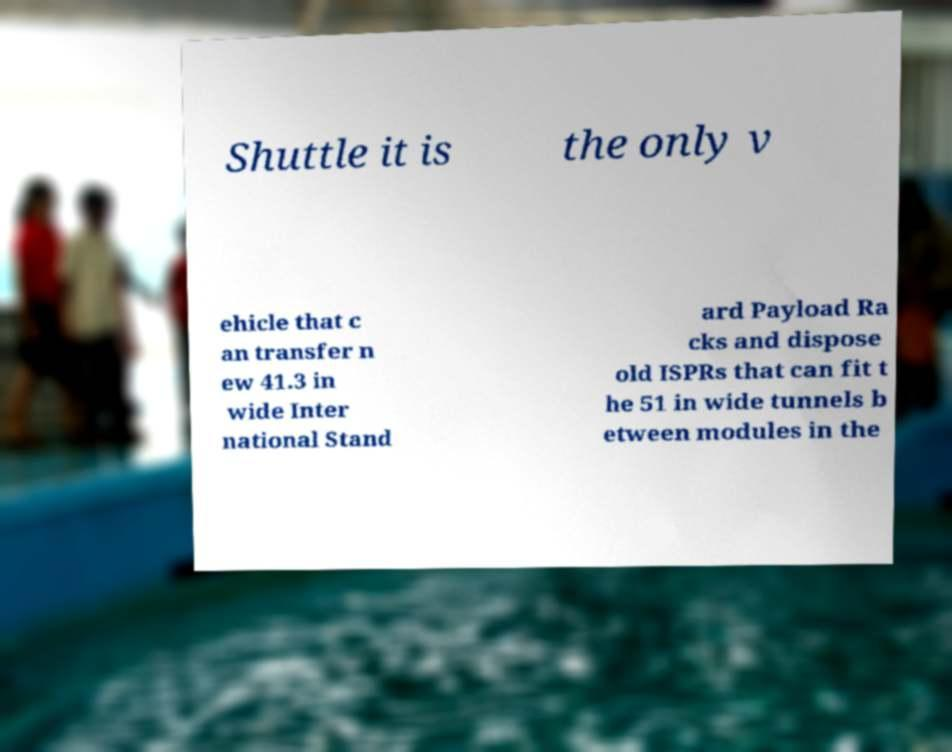What messages or text are displayed in this image? I need them in a readable, typed format. Shuttle it is the only v ehicle that c an transfer n ew 41.3 in wide Inter national Stand ard Payload Ra cks and dispose old ISPRs that can fit t he 51 in wide tunnels b etween modules in the 